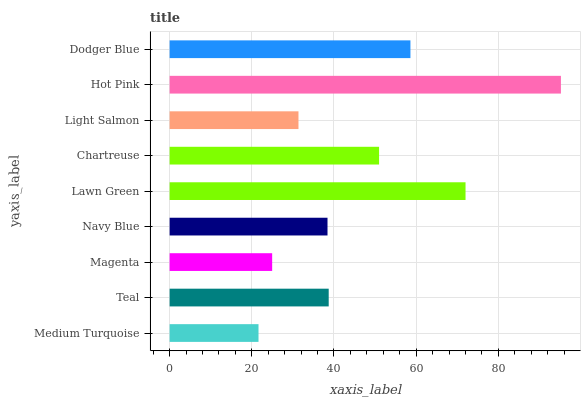Is Medium Turquoise the minimum?
Answer yes or no. Yes. Is Hot Pink the maximum?
Answer yes or no. Yes. Is Teal the minimum?
Answer yes or no. No. Is Teal the maximum?
Answer yes or no. No. Is Teal greater than Medium Turquoise?
Answer yes or no. Yes. Is Medium Turquoise less than Teal?
Answer yes or no. Yes. Is Medium Turquoise greater than Teal?
Answer yes or no. No. Is Teal less than Medium Turquoise?
Answer yes or no. No. Is Teal the high median?
Answer yes or no. Yes. Is Teal the low median?
Answer yes or no. Yes. Is Dodger Blue the high median?
Answer yes or no. No. Is Lawn Green the low median?
Answer yes or no. No. 